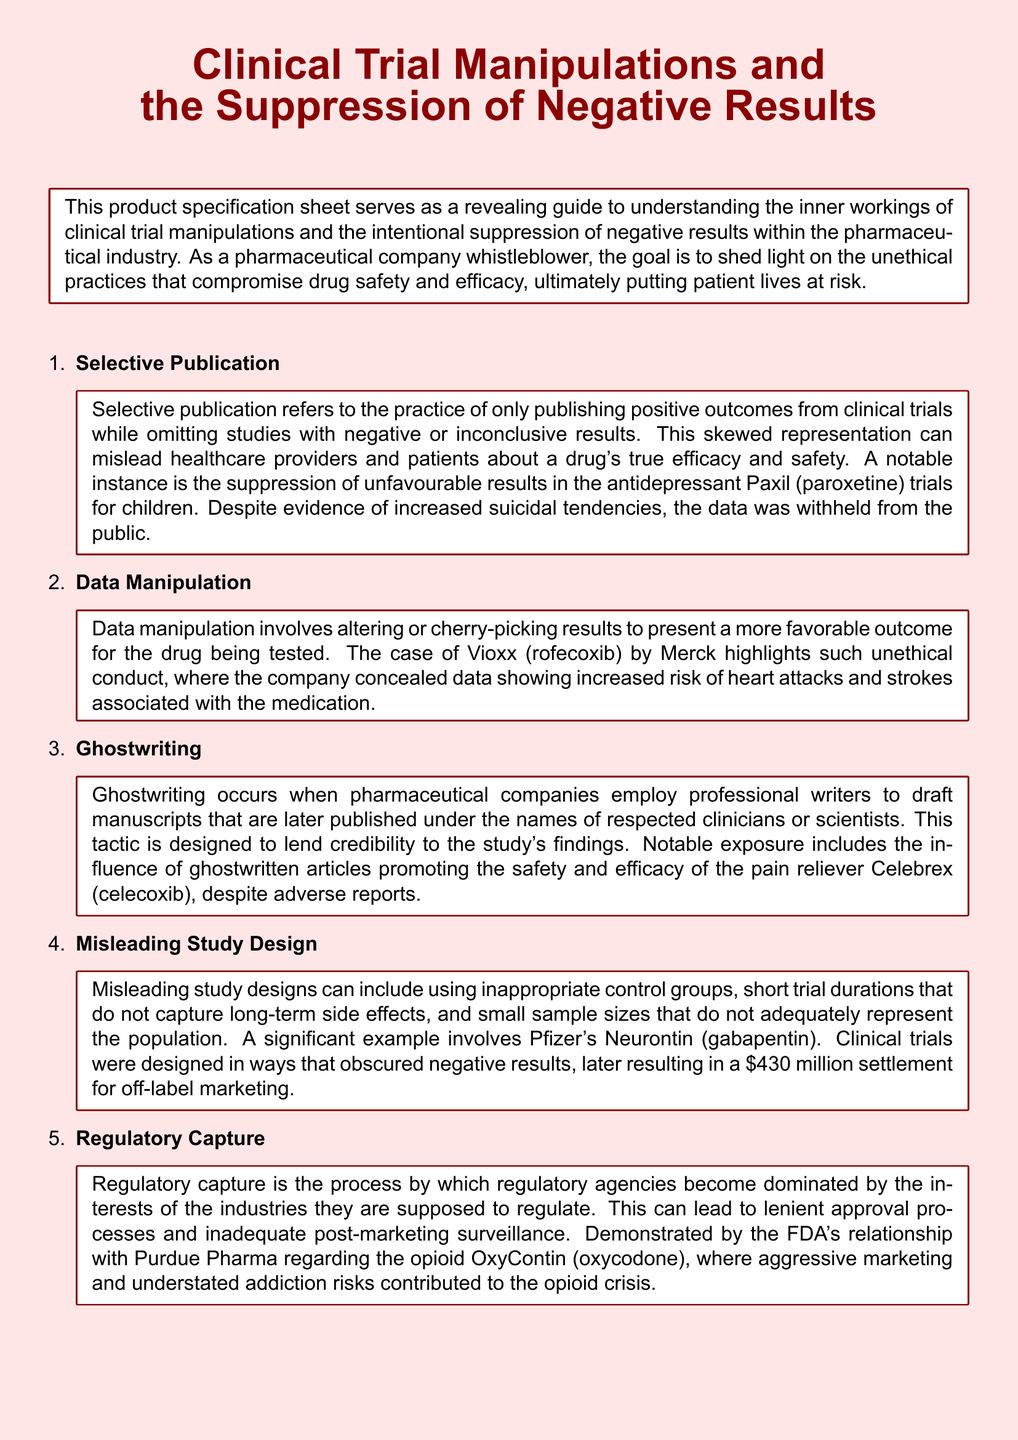What is the title of the document? The title of the document is found at the top of the rendered document, which addresses clinical trial manipulations and negative results suppression.
Answer: Clinical Trial Manipulations and the Suppression of Negative Results What drug was involved in the Paxil trials? The document mentions Paxil as a drug related to the suppression of unfavourable results in clinical trials for children.
Answer: Paxil What is the significant settlement amount mentioned in the document? The document cites a notable settlement of $430 million related to misleading study designs involving a specific drug.
Answer: $430 million Who was involved in the ghostwriting practice mentioned? The practice of ghostwriting involved pharmaceutical companies employing professional writers, often published under the names of respected clinicians or scientists.
Answer: Pharmaceutical companies What was the drug linked to increased risk of heart attacks and strokes? The document references Vioxx as the drug associated with concealed data showing increased health risks.
Answer: Vioxx Which regulatory agency is mentioned in relation to Purdue Pharma? The FDA is referenced in connection with regulatory capture regarding Purdue Pharma and OxyContin.
Answer: FDA What term describes the practice of selectively publishing positive outcomes only? The document defines the practice of only publishing positive outcomes while omitting negative results as selective publication.
Answer: Selective Publication What type of manipulation involves altering or cherry-picking results? The alteration or selective presentation of trial results is referred to as data manipulation within the document.
Answer: Data Manipulation 